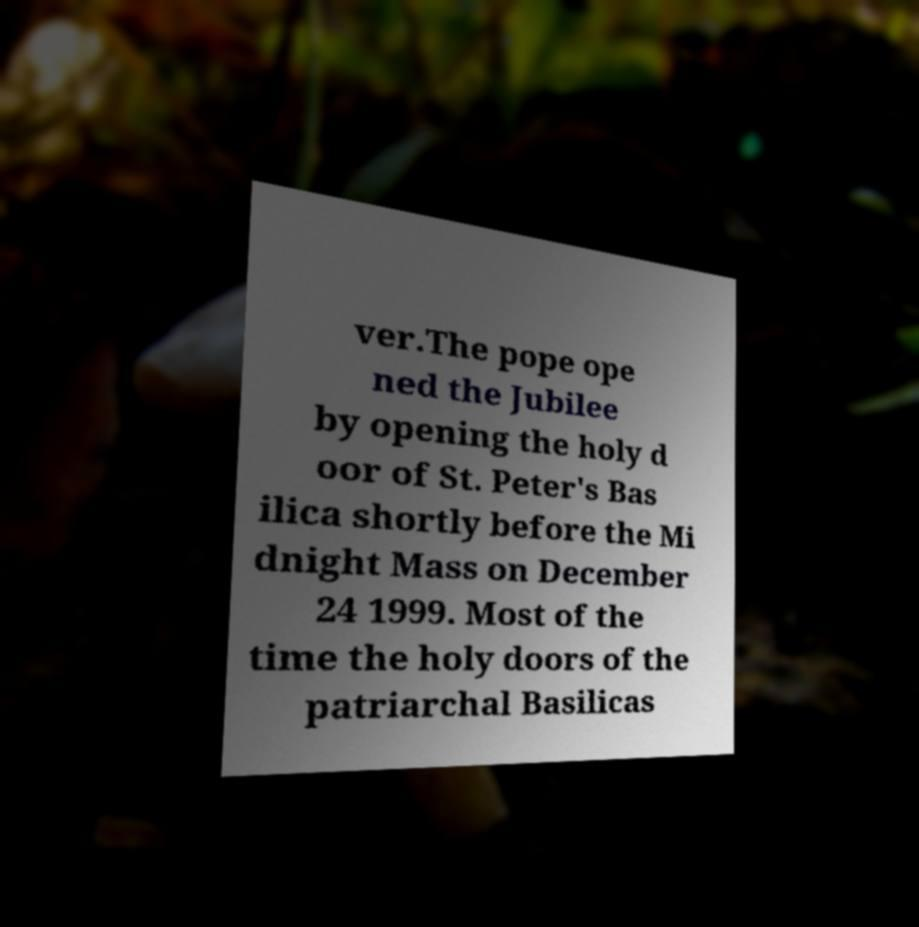There's text embedded in this image that I need extracted. Can you transcribe it verbatim? ver.The pope ope ned the Jubilee by opening the holy d oor of St. Peter's Bas ilica shortly before the Mi dnight Mass on December 24 1999. Most of the time the holy doors of the patriarchal Basilicas 